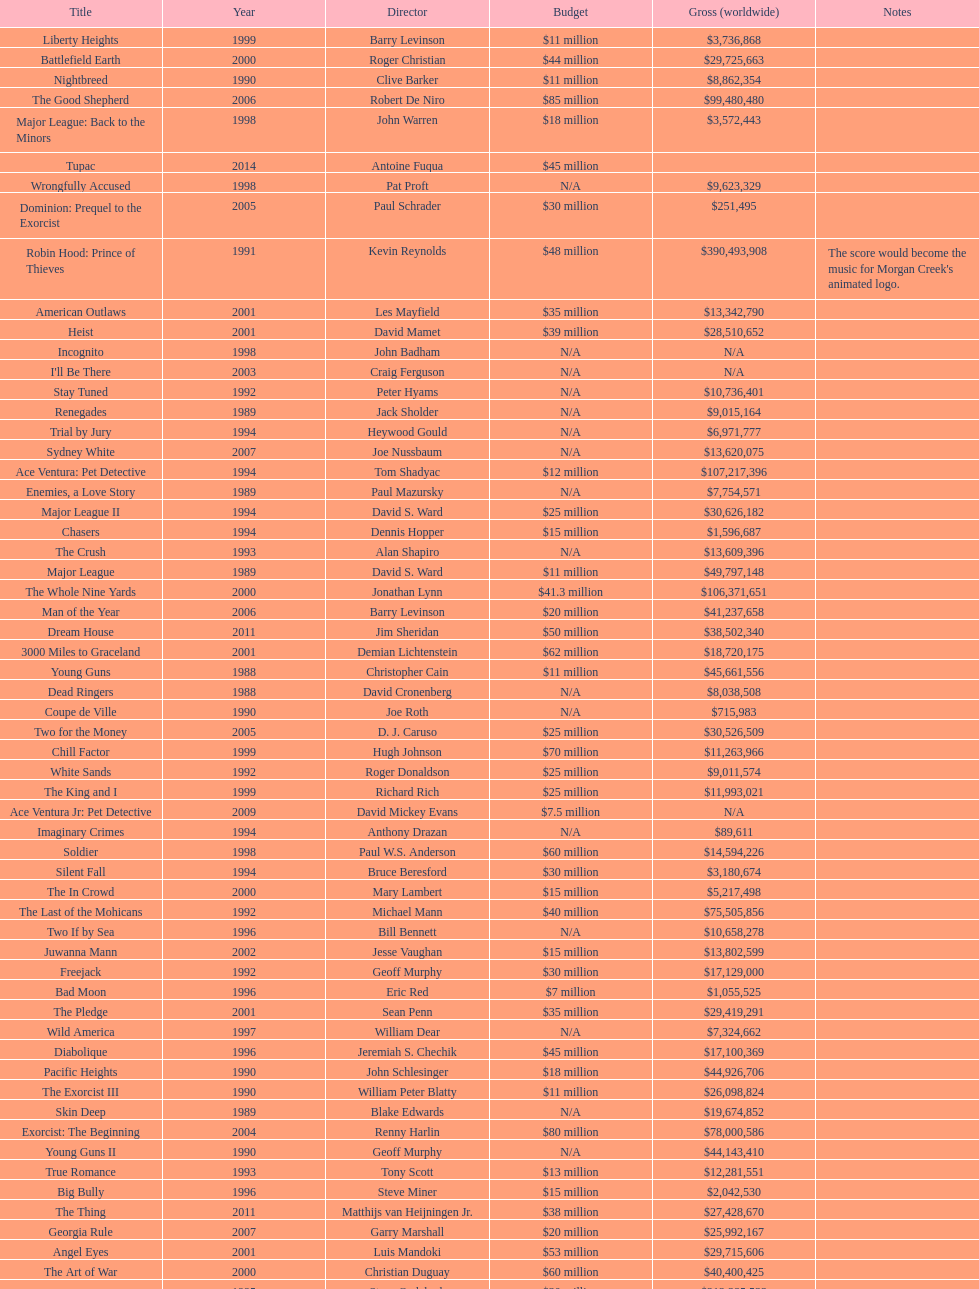Was the budget for young guns more or less than freejack's budget? Less. 